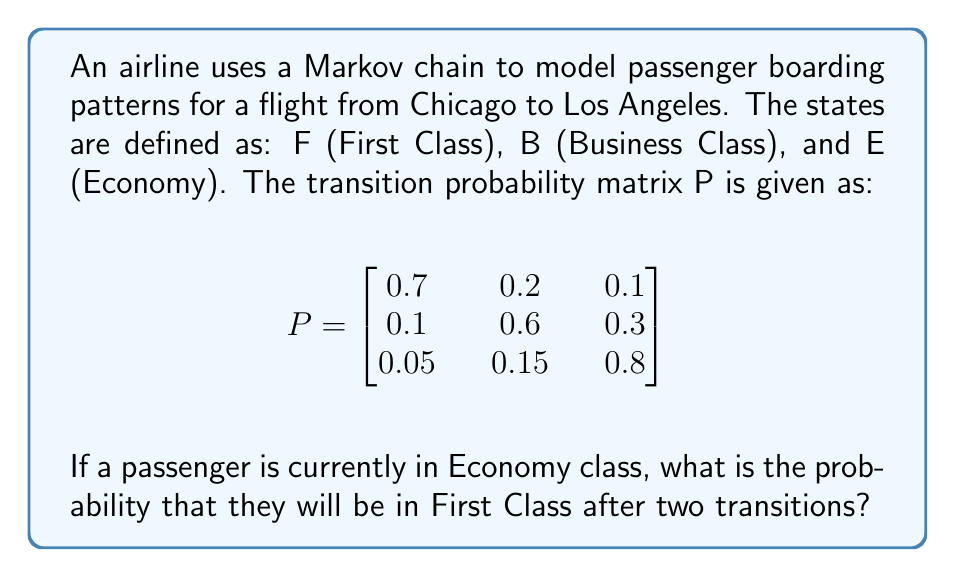Can you answer this question? To solve this problem, we need to use the Chapman-Kolmogorov equations and calculate the two-step transition probability. Let's break it down step-by-step:

1) We start in Economy (E) and want to end in First Class (F) after two transitions.

2) The two-step transition probability matrix is given by $P^2$. We need to calculate this first:

   $$P^2 = P \times P = \begin{bmatrix}
   0.7 & 0.2 & 0.1 \\
   0.1 & 0.6 & 0.3 \\
   0.05 & 0.15 & 0.8
   \end{bmatrix} \times \begin{bmatrix}
   0.7 & 0.2 & 0.1 \\
   0.1 & 0.6 & 0.3 \\
   0.05 & 0.15 & 0.8
   \end{bmatrix}$$

3) Multiplying these matrices:

   $$P^2 = \begin{bmatrix}
   0.52 & 0.29 & 0.19 \\
   0.16 & 0.45 & 0.39 \\
   0.1075 & 0.2475 & 0.645
   \end{bmatrix}$$

4) The probability we're looking for is the transition from E to F after two steps, which is the element in the third row, first column of $P^2$.

5) Therefore, the probability of transitioning from Economy to First Class after two transitions is 0.1075 or 10.75%.
Answer: 0.1075 